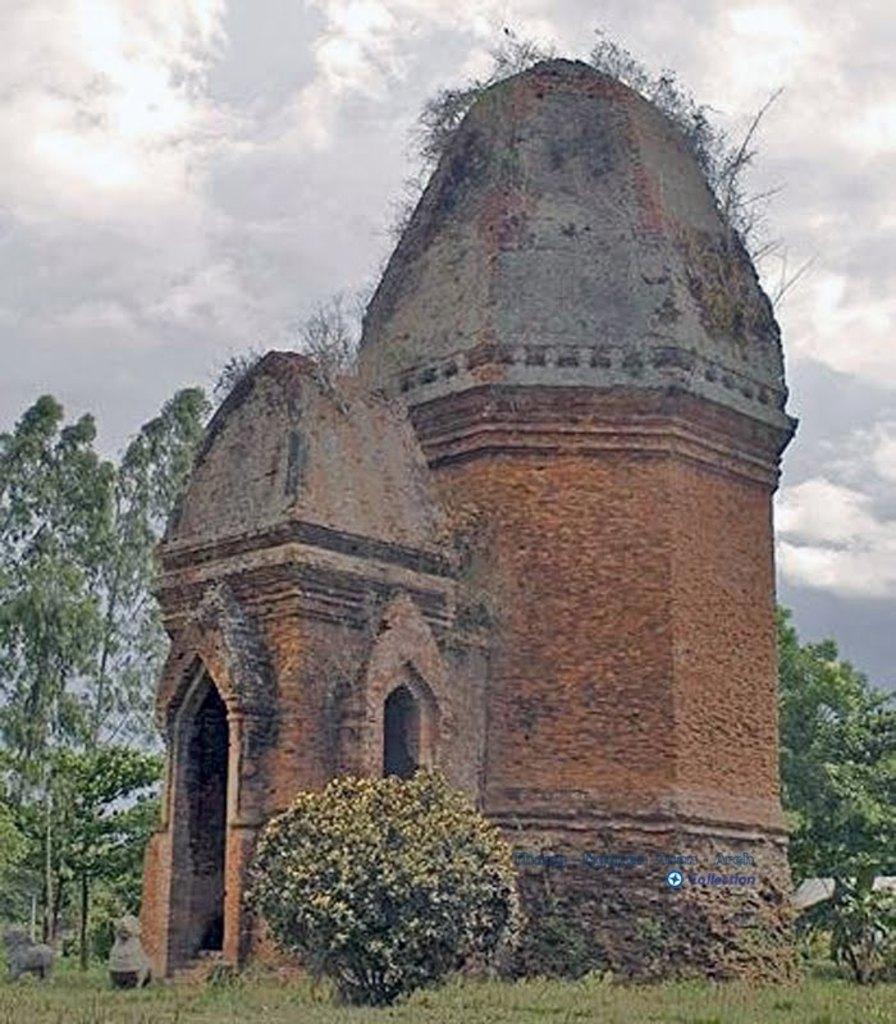Please provide a concise description of this image. In this image there is a monument. In front of the monument there are stone structures. Around the monument there are bushes and trees. At the bottom of the image there is grass on the surface. At the top of the image there are clouds in the sky. There is some text on the image. 